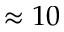Convert formula to latex. <formula><loc_0><loc_0><loc_500><loc_500>\approx 1 0</formula> 